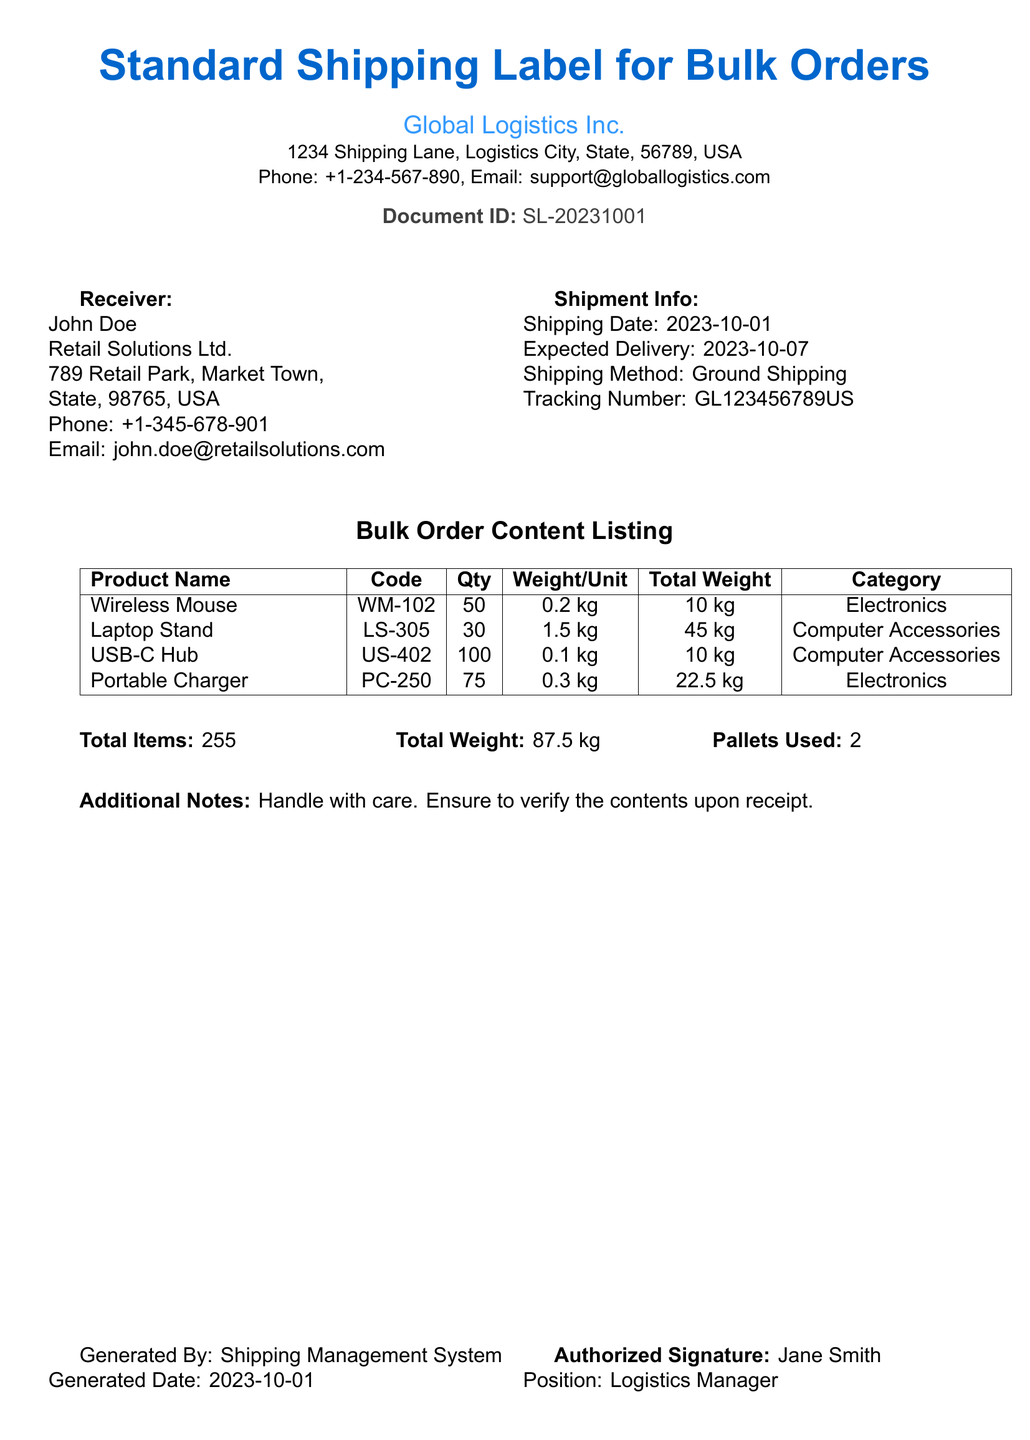what is the shipping date? The shipping date is clearly stated in the document as "2023-10-01."
Answer: 2023-10-01 who is the receiver? The document specifies the receiver's name as "John Doe."
Answer: John Doe what is the total weight of the shipment? The total weight is calculated and listed as "87.5 kg."
Answer: 87.5 kg how many pallets are used? The document indicates that "2" pallets are used for the shipment.
Answer: 2 what is the email of the recipient? The email provided in the document for the recipient is "john.doe@retailsolutions.com."
Answer: john.doe@retailsolutions.com what is the product name for the code US-402? The document lists "USB-C Hub" as the product name corresponding to the code US-402.
Answer: USB-C Hub what is the total number of items? The document shows that the total number of items is "255."
Answer: 255 what are the additional notes? The additional notes section specifies "Handle with care. Ensure to verify the contents upon receipt."
Answer: Handle with care. Ensure to verify the contents upon receipt what is the authorized signature? The authorized signature in the document is identified as "Jane Smith."
Answer: Jane Smith 